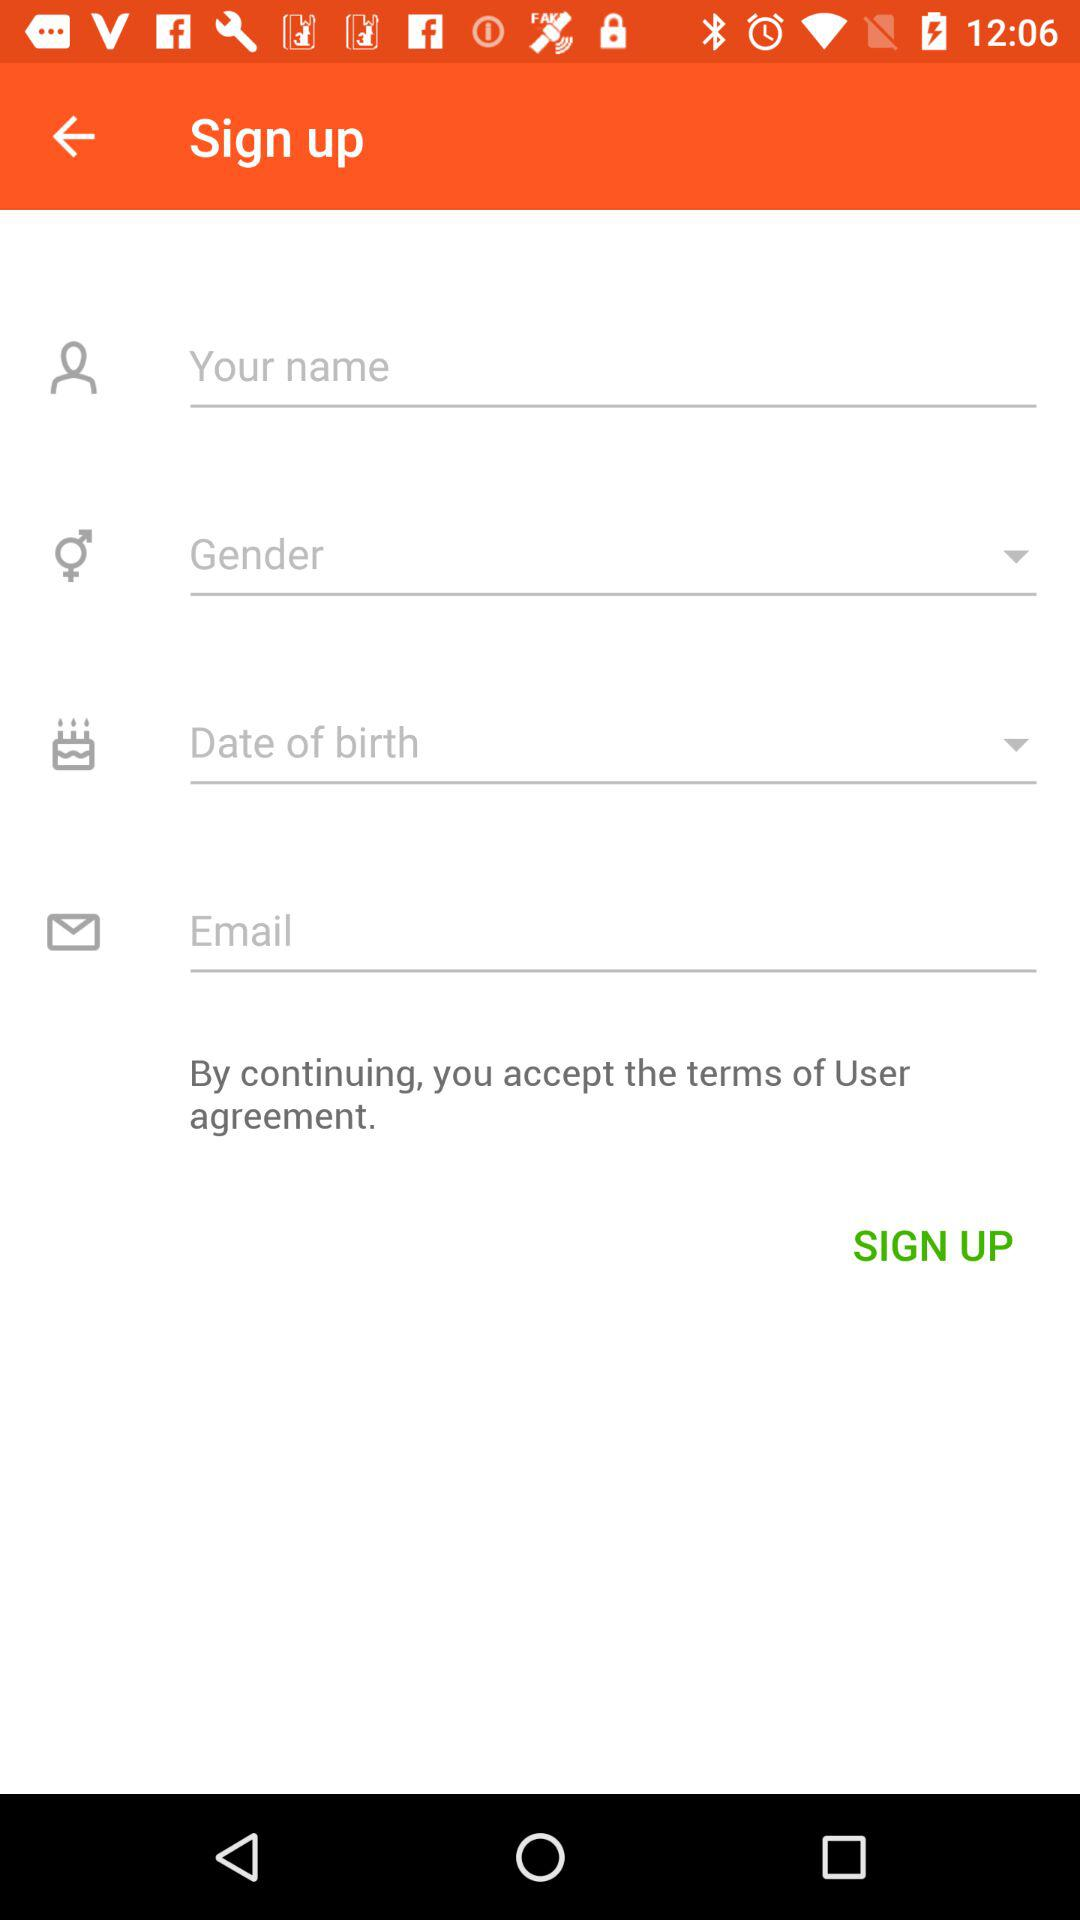How many fields are required before the user can sign up?
Answer the question using a single word or phrase. 4 